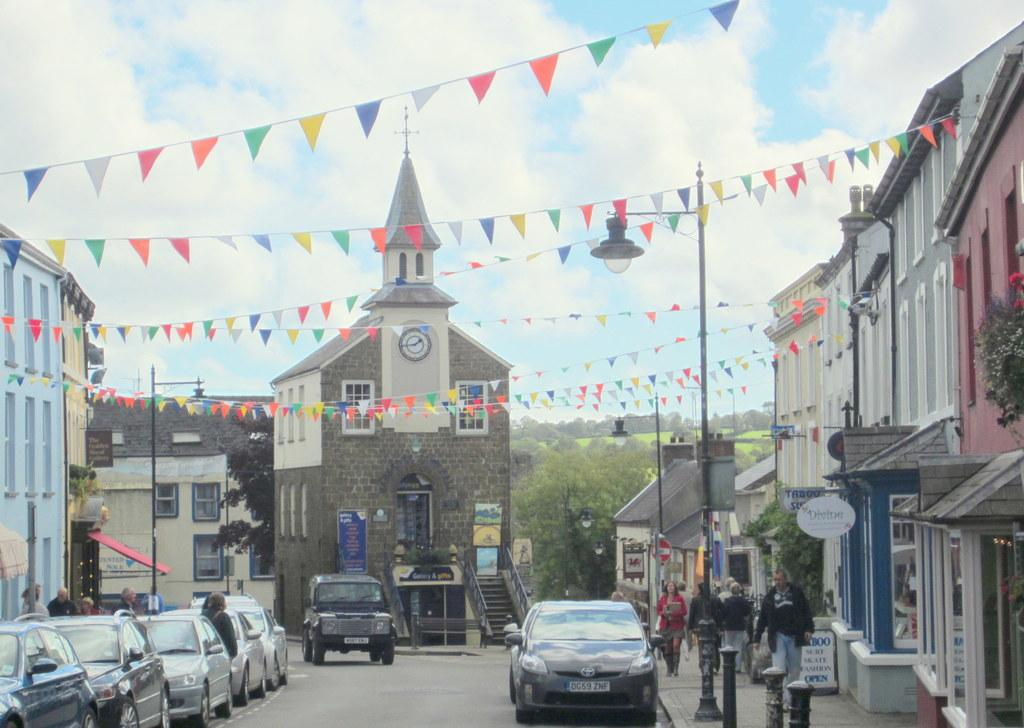What can be seen on the road in the image? There are people on the road in the image. What type of structures are visible in the image? There are buildings in the image. What are the light poles used for in the image? Light poles are visible in the image, likely for providing illumination. What types of transportation are present in the image? Vehicles are present in the image. What type of vegetation is in the image? Trees are in the image. What can be read in the image? Boards with text are in the image. What architectural feature is visible in the image? Stairs are visible in the image. What type of plant is in the image? There is a plant in the image. What is visible in the sky in the image? The sky is visible in the image. Where is the coal mine located in the image? There is no coal mine present in the image. What type of food is being served in the lunchroom in the image? There is no lunchroom present in the image. 